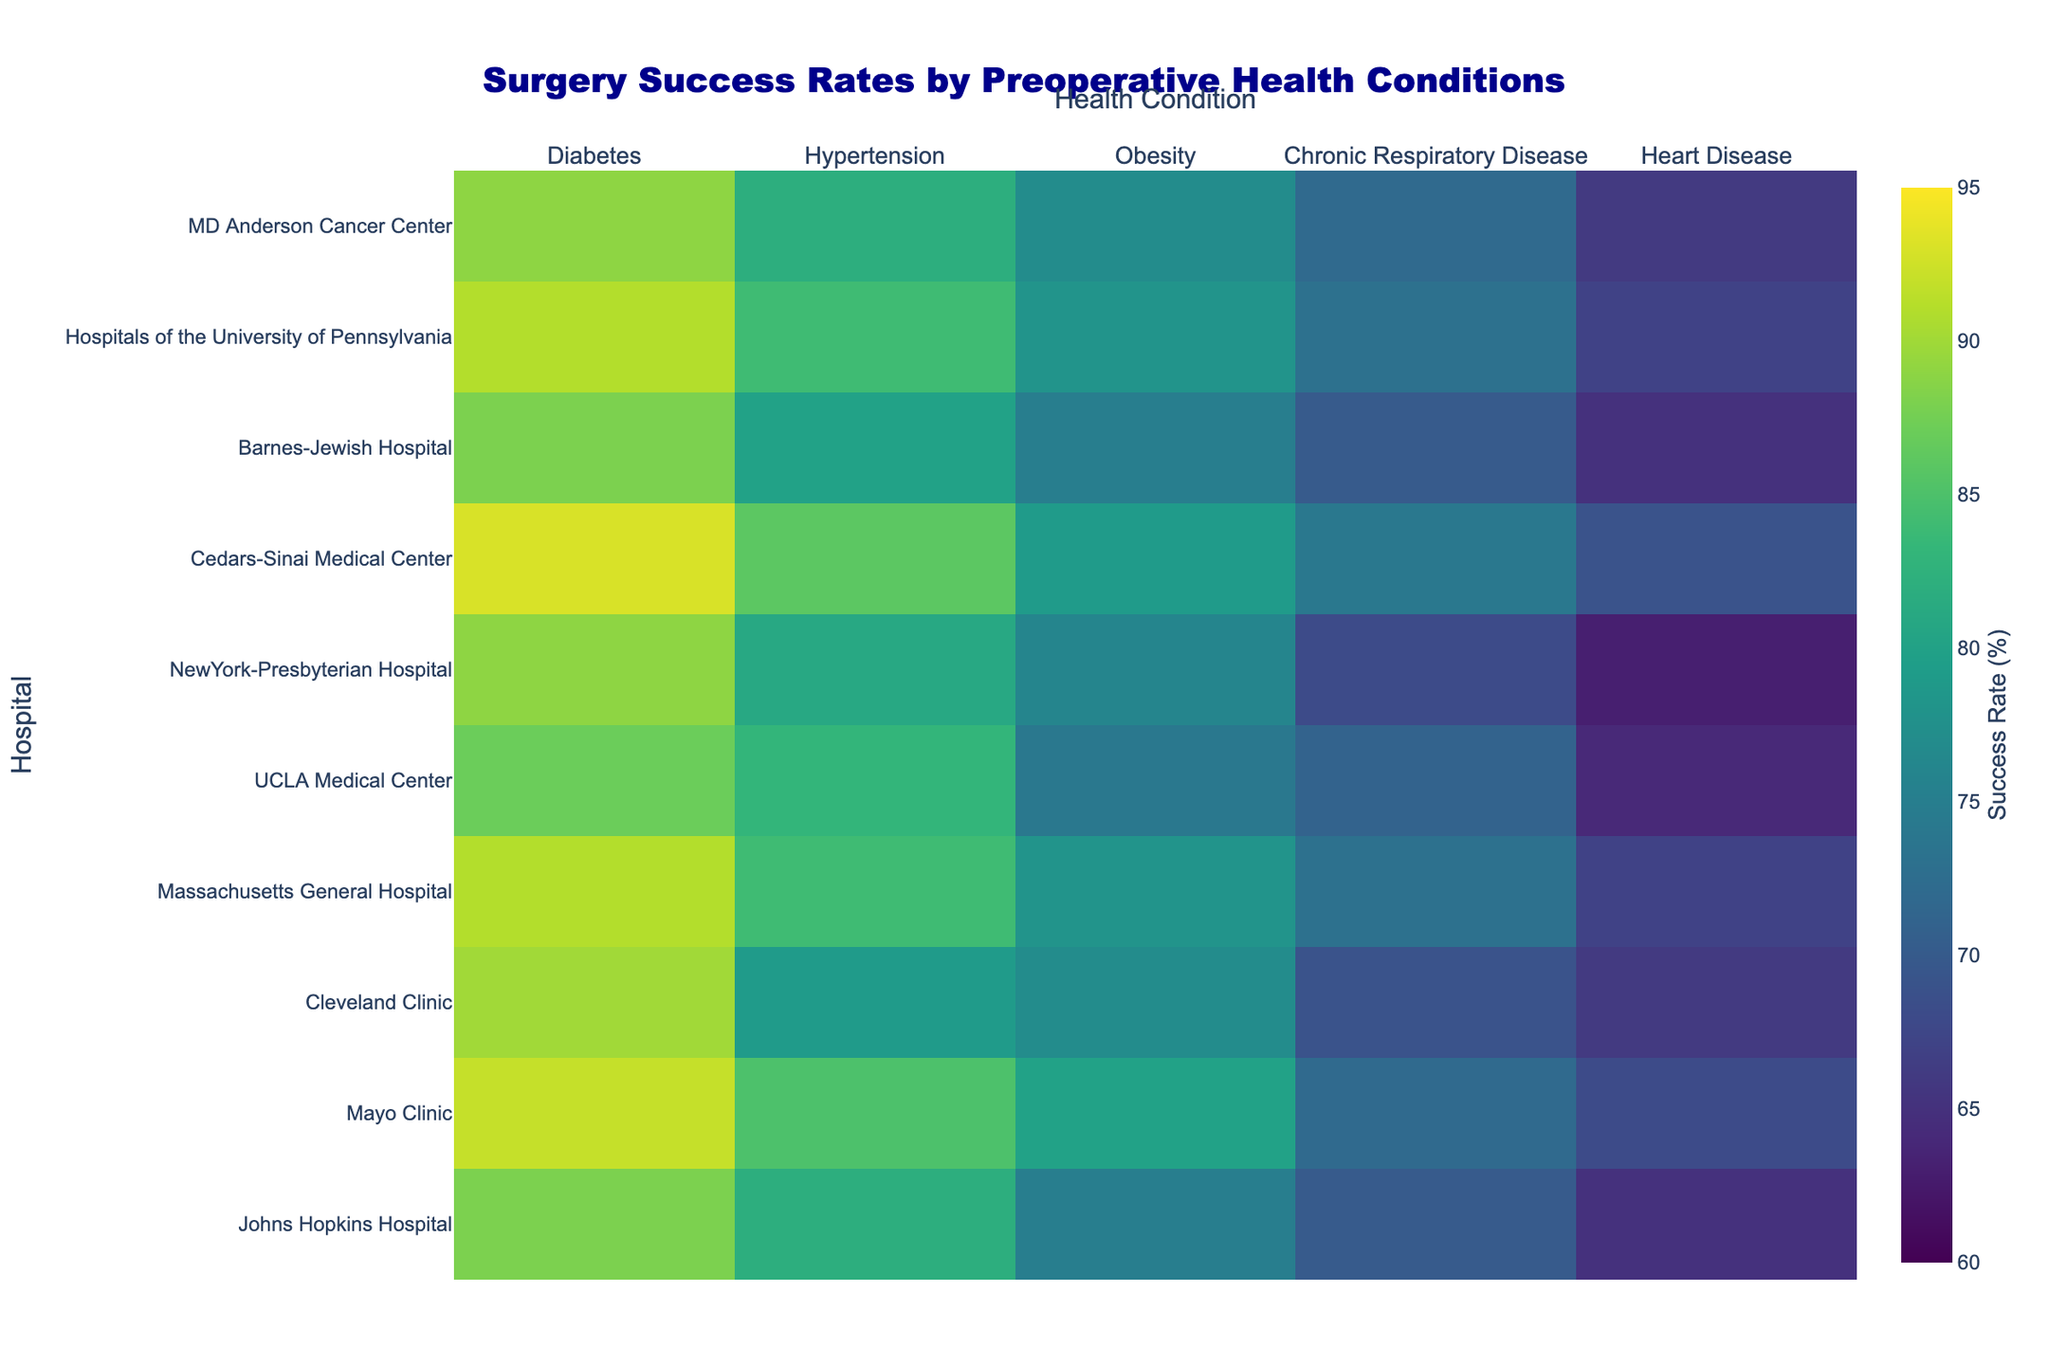What is the title of the heatmap? The title of the heatmap can be found at the top of the figure, usually highlighted in a larger, bold font. This title summarises what the heatmap is representing.
Answer: Surgery Success Rates by Preoperative Health Conditions Which hospital has the highest surgery success rate for Heart Disease? To find the hospital with the highest success rate for Heart Disease, locate the "Heart Disease" column and identify the highest value.
Answer: Cedars-Sinai Medical Center What is the color scale range used in the heatmap? The color scale range can be identified by checking the color bar, which shows the minimum and maximum values it represents.
Answer: 60 to 95 How does the success rate for Hypertension at Mayo Clinic compare to that at Cedars-Sinai Medical Center? First, locate the success rates for Hypertension at both Mayo Clinic and Cedars-Sinai Medical Center. Then, compare these two values. Mayo Clinic has a success rate of 85%, and Cedars-Sinai Medical Center has a success rate of 86%.
Answer: Cedars-Sinai Medical Center is higher by 1% Which health condition generally shows the lowest surgery success rates across all hospitals? Visually scan the heatmap to identify the health condition that consistently appears with darker colors, which indicate lower success rates.
Answer: Heart Disease What is the average success rate for surgeries related to Obesity across all hospitals? Sum the success rates for Obesity for all hospitals and divide by the number of hospitals. (75 + 80 + 77 + 78 + 74 + 76 + 79 + 75 + 78 + 77) / 10 = 76.9
Answer: 76.9 Which hospital has the most consistent surgery success rates across different health conditions? Consistent success rates would show less variation in colors across the health condition columns for a particular hospital. Cedars-Sinai Medical Center has success rates ranging from 74% to 86%, displaying more consistency compared to others.
Answer: Cedars-Sinai Medical Center What is the difference in surgery success rates for Diabetes between the hospital with the highest rate and the one with the lowest rate? Identify the highest (Cedars-Sinai Medical Center: 93%) and lowest (Johns Hopkins Hospital: 88%) success rates for Diabetes and calculate the difference. 93% - 88% = 5%.
Answer: 5% Which three hospitals have the highest average surgery success rates across all health conditions and what are these averages? Calculate the average success rates across all conditions for each hospital, then find the highest three. For example, Cedars-Sinai Medical Center's average is (93+86+79+74+69)/5 = 80.2. Calculate similarly for all hospitals and identify the top three.
Answer: Mayo Clinic: 79.4, Cedars-Sinai Medical Center: 80.2, Massachusetts General Hospital: 78.6 Is there a hospital where the surgery success rates for Chronic Respiratory Disease exceed 70%? Check each hospital's surgery success rate for Chronic Respiratory Disease and verify if it's greater than 70%. For example, Johns Hopkins Hospital has 70%, so it doesn't exceed, Mayo Clinic is 72%, so it does.
Answer: Yes, Mayo Clinic, Massachusetts General Hospital, Cedars-Sinai Medical Center, UCLA Medical Center, and MD Anderson Cancer Center have rates exceeding 70% How does NewYork-Presbyterian Hospital's success rate for Chronic Respiratory Disease compare to its rates for other health conditions? Obtain the success rate for Chronic Respiratory Disease (68%) and compare it with the rates for Diabetes (89%), Hypertension (81%), Obesity (76%), and Heart Disease (63%). The rates for Diabetes, Hypertension, and Obesity are higher but lower than Heart Disease.
Answer: Higher than Heart Disease, but lower than Diabetes, Hypertension, and Obesity 